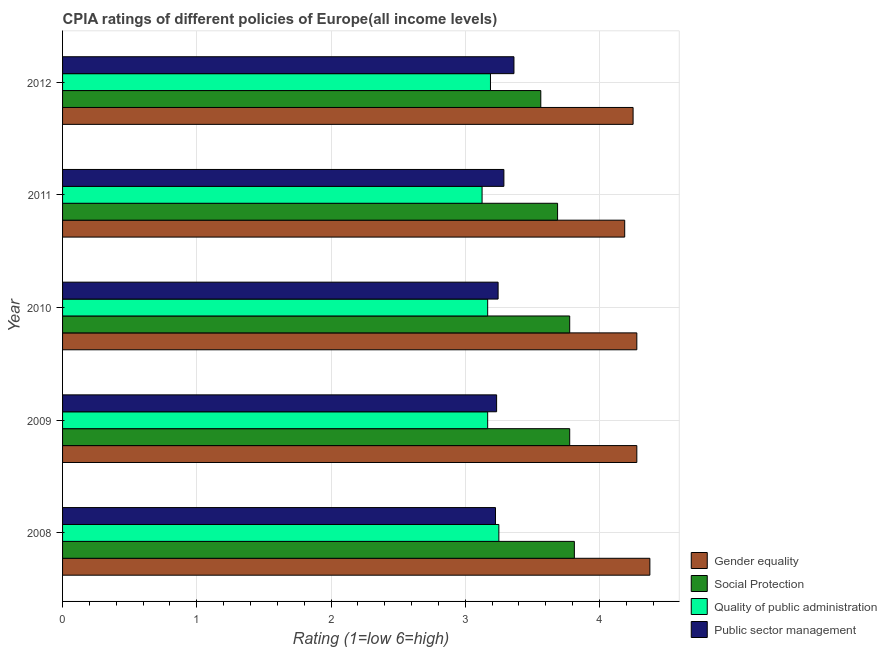How many groups of bars are there?
Give a very brief answer. 5. How many bars are there on the 5th tick from the bottom?
Offer a terse response. 4. What is the label of the 5th group of bars from the top?
Offer a terse response. 2008. In how many cases, is the number of bars for a given year not equal to the number of legend labels?
Make the answer very short. 0. What is the cpia rating of public sector management in 2010?
Give a very brief answer. 3.24. Across all years, what is the maximum cpia rating of gender equality?
Your answer should be very brief. 4.38. Across all years, what is the minimum cpia rating of quality of public administration?
Provide a succinct answer. 3.12. What is the total cpia rating of gender equality in the graph?
Ensure brevity in your answer.  21.37. What is the difference between the cpia rating of gender equality in 2009 and that in 2011?
Offer a very short reply. 0.09. What is the difference between the cpia rating of public sector management in 2009 and the cpia rating of social protection in 2011?
Ensure brevity in your answer.  -0.45. What is the average cpia rating of public sector management per year?
Offer a very short reply. 3.27. In the year 2011, what is the difference between the cpia rating of public sector management and cpia rating of quality of public administration?
Offer a terse response. 0.16. In how many years, is the cpia rating of social protection greater than 1.4 ?
Your answer should be compact. 5. What is the ratio of the cpia rating of public sector management in 2011 to that in 2012?
Make the answer very short. 0.98. Is the cpia rating of public sector management in 2010 less than that in 2011?
Ensure brevity in your answer.  Yes. Is the difference between the cpia rating of public sector management in 2009 and 2010 greater than the difference between the cpia rating of quality of public administration in 2009 and 2010?
Your answer should be very brief. No. What is the difference between the highest and the second highest cpia rating of quality of public administration?
Your response must be concise. 0.06. What is the difference between the highest and the lowest cpia rating of gender equality?
Provide a succinct answer. 0.19. In how many years, is the cpia rating of quality of public administration greater than the average cpia rating of quality of public administration taken over all years?
Keep it short and to the point. 2. Is the sum of the cpia rating of quality of public administration in 2008 and 2010 greater than the maximum cpia rating of public sector management across all years?
Keep it short and to the point. Yes. Is it the case that in every year, the sum of the cpia rating of gender equality and cpia rating of social protection is greater than the sum of cpia rating of public sector management and cpia rating of quality of public administration?
Provide a short and direct response. Yes. What does the 1st bar from the top in 2008 represents?
Give a very brief answer. Public sector management. What does the 3rd bar from the bottom in 2008 represents?
Provide a succinct answer. Quality of public administration. Is it the case that in every year, the sum of the cpia rating of gender equality and cpia rating of social protection is greater than the cpia rating of quality of public administration?
Offer a terse response. Yes. Does the graph contain any zero values?
Your response must be concise. No. Where does the legend appear in the graph?
Provide a succinct answer. Bottom right. What is the title of the graph?
Give a very brief answer. CPIA ratings of different policies of Europe(all income levels). Does "Social Assistance" appear as one of the legend labels in the graph?
Your response must be concise. No. What is the label or title of the X-axis?
Give a very brief answer. Rating (1=low 6=high). What is the Rating (1=low 6=high) of Gender equality in 2008?
Give a very brief answer. 4.38. What is the Rating (1=low 6=high) of Social Protection in 2008?
Your answer should be very brief. 3.81. What is the Rating (1=low 6=high) in Public sector management in 2008?
Provide a short and direct response. 3.23. What is the Rating (1=low 6=high) in Gender equality in 2009?
Offer a terse response. 4.28. What is the Rating (1=low 6=high) in Social Protection in 2009?
Your response must be concise. 3.78. What is the Rating (1=low 6=high) in Quality of public administration in 2009?
Offer a very short reply. 3.17. What is the Rating (1=low 6=high) of Public sector management in 2009?
Offer a terse response. 3.23. What is the Rating (1=low 6=high) in Gender equality in 2010?
Your answer should be very brief. 4.28. What is the Rating (1=low 6=high) in Social Protection in 2010?
Ensure brevity in your answer.  3.78. What is the Rating (1=low 6=high) in Quality of public administration in 2010?
Keep it short and to the point. 3.17. What is the Rating (1=low 6=high) of Public sector management in 2010?
Your answer should be very brief. 3.24. What is the Rating (1=low 6=high) of Gender equality in 2011?
Give a very brief answer. 4.19. What is the Rating (1=low 6=high) of Social Protection in 2011?
Keep it short and to the point. 3.69. What is the Rating (1=low 6=high) in Quality of public administration in 2011?
Offer a very short reply. 3.12. What is the Rating (1=low 6=high) in Public sector management in 2011?
Your answer should be very brief. 3.29. What is the Rating (1=low 6=high) in Gender equality in 2012?
Your answer should be very brief. 4.25. What is the Rating (1=low 6=high) of Social Protection in 2012?
Your answer should be very brief. 3.56. What is the Rating (1=low 6=high) of Quality of public administration in 2012?
Make the answer very short. 3.19. What is the Rating (1=low 6=high) of Public sector management in 2012?
Your answer should be very brief. 3.36. Across all years, what is the maximum Rating (1=low 6=high) in Gender equality?
Your answer should be very brief. 4.38. Across all years, what is the maximum Rating (1=low 6=high) of Social Protection?
Your response must be concise. 3.81. Across all years, what is the maximum Rating (1=low 6=high) in Public sector management?
Provide a succinct answer. 3.36. Across all years, what is the minimum Rating (1=low 6=high) of Gender equality?
Your response must be concise. 4.19. Across all years, what is the minimum Rating (1=low 6=high) of Social Protection?
Provide a succinct answer. 3.56. Across all years, what is the minimum Rating (1=low 6=high) in Quality of public administration?
Keep it short and to the point. 3.12. Across all years, what is the minimum Rating (1=low 6=high) in Public sector management?
Offer a terse response. 3.23. What is the total Rating (1=low 6=high) in Gender equality in the graph?
Provide a short and direct response. 21.37. What is the total Rating (1=low 6=high) in Social Protection in the graph?
Offer a very short reply. 18.62. What is the total Rating (1=low 6=high) of Quality of public administration in the graph?
Offer a very short reply. 15.9. What is the total Rating (1=low 6=high) of Public sector management in the graph?
Offer a very short reply. 16.35. What is the difference between the Rating (1=low 6=high) in Gender equality in 2008 and that in 2009?
Provide a succinct answer. 0.1. What is the difference between the Rating (1=low 6=high) of Social Protection in 2008 and that in 2009?
Your answer should be compact. 0.03. What is the difference between the Rating (1=low 6=high) in Quality of public administration in 2008 and that in 2009?
Give a very brief answer. 0.08. What is the difference between the Rating (1=low 6=high) in Public sector management in 2008 and that in 2009?
Your answer should be compact. -0.01. What is the difference between the Rating (1=low 6=high) of Gender equality in 2008 and that in 2010?
Offer a very short reply. 0.1. What is the difference between the Rating (1=low 6=high) in Social Protection in 2008 and that in 2010?
Provide a short and direct response. 0.03. What is the difference between the Rating (1=low 6=high) of Quality of public administration in 2008 and that in 2010?
Keep it short and to the point. 0.08. What is the difference between the Rating (1=low 6=high) of Public sector management in 2008 and that in 2010?
Offer a very short reply. -0.02. What is the difference between the Rating (1=low 6=high) in Gender equality in 2008 and that in 2011?
Provide a short and direct response. 0.19. What is the difference between the Rating (1=low 6=high) of Social Protection in 2008 and that in 2011?
Offer a terse response. 0.12. What is the difference between the Rating (1=low 6=high) in Quality of public administration in 2008 and that in 2011?
Offer a very short reply. 0.12. What is the difference between the Rating (1=low 6=high) in Public sector management in 2008 and that in 2011?
Your answer should be very brief. -0.06. What is the difference between the Rating (1=low 6=high) in Quality of public administration in 2008 and that in 2012?
Give a very brief answer. 0.06. What is the difference between the Rating (1=low 6=high) in Public sector management in 2008 and that in 2012?
Give a very brief answer. -0.14. What is the difference between the Rating (1=low 6=high) in Gender equality in 2009 and that in 2010?
Your answer should be compact. 0. What is the difference between the Rating (1=low 6=high) in Public sector management in 2009 and that in 2010?
Make the answer very short. -0.01. What is the difference between the Rating (1=low 6=high) in Gender equality in 2009 and that in 2011?
Make the answer very short. 0.09. What is the difference between the Rating (1=low 6=high) in Social Protection in 2009 and that in 2011?
Your answer should be very brief. 0.09. What is the difference between the Rating (1=low 6=high) in Quality of public administration in 2009 and that in 2011?
Ensure brevity in your answer.  0.04. What is the difference between the Rating (1=low 6=high) in Public sector management in 2009 and that in 2011?
Keep it short and to the point. -0.05. What is the difference between the Rating (1=low 6=high) in Gender equality in 2009 and that in 2012?
Offer a terse response. 0.03. What is the difference between the Rating (1=low 6=high) in Social Protection in 2009 and that in 2012?
Your answer should be very brief. 0.22. What is the difference between the Rating (1=low 6=high) of Quality of public administration in 2009 and that in 2012?
Keep it short and to the point. -0.02. What is the difference between the Rating (1=low 6=high) in Public sector management in 2009 and that in 2012?
Provide a succinct answer. -0.13. What is the difference between the Rating (1=low 6=high) in Gender equality in 2010 and that in 2011?
Your answer should be very brief. 0.09. What is the difference between the Rating (1=low 6=high) of Social Protection in 2010 and that in 2011?
Provide a short and direct response. 0.09. What is the difference between the Rating (1=low 6=high) in Quality of public administration in 2010 and that in 2011?
Keep it short and to the point. 0.04. What is the difference between the Rating (1=low 6=high) in Public sector management in 2010 and that in 2011?
Keep it short and to the point. -0.04. What is the difference between the Rating (1=low 6=high) of Gender equality in 2010 and that in 2012?
Provide a short and direct response. 0.03. What is the difference between the Rating (1=low 6=high) in Social Protection in 2010 and that in 2012?
Offer a very short reply. 0.22. What is the difference between the Rating (1=low 6=high) of Quality of public administration in 2010 and that in 2012?
Provide a succinct answer. -0.02. What is the difference between the Rating (1=low 6=high) in Public sector management in 2010 and that in 2012?
Your answer should be compact. -0.12. What is the difference between the Rating (1=low 6=high) in Gender equality in 2011 and that in 2012?
Keep it short and to the point. -0.06. What is the difference between the Rating (1=low 6=high) in Quality of public administration in 2011 and that in 2012?
Offer a terse response. -0.06. What is the difference between the Rating (1=low 6=high) of Public sector management in 2011 and that in 2012?
Make the answer very short. -0.07. What is the difference between the Rating (1=low 6=high) in Gender equality in 2008 and the Rating (1=low 6=high) in Social Protection in 2009?
Give a very brief answer. 0.6. What is the difference between the Rating (1=low 6=high) of Gender equality in 2008 and the Rating (1=low 6=high) of Quality of public administration in 2009?
Ensure brevity in your answer.  1.21. What is the difference between the Rating (1=low 6=high) of Gender equality in 2008 and the Rating (1=low 6=high) of Public sector management in 2009?
Offer a terse response. 1.14. What is the difference between the Rating (1=low 6=high) in Social Protection in 2008 and the Rating (1=low 6=high) in Quality of public administration in 2009?
Keep it short and to the point. 0.65. What is the difference between the Rating (1=low 6=high) of Social Protection in 2008 and the Rating (1=low 6=high) of Public sector management in 2009?
Give a very brief answer. 0.58. What is the difference between the Rating (1=low 6=high) of Quality of public administration in 2008 and the Rating (1=low 6=high) of Public sector management in 2009?
Your answer should be compact. 0.02. What is the difference between the Rating (1=low 6=high) in Gender equality in 2008 and the Rating (1=low 6=high) in Social Protection in 2010?
Provide a succinct answer. 0.6. What is the difference between the Rating (1=low 6=high) in Gender equality in 2008 and the Rating (1=low 6=high) in Quality of public administration in 2010?
Your response must be concise. 1.21. What is the difference between the Rating (1=low 6=high) of Gender equality in 2008 and the Rating (1=low 6=high) of Public sector management in 2010?
Offer a terse response. 1.13. What is the difference between the Rating (1=low 6=high) of Social Protection in 2008 and the Rating (1=low 6=high) of Quality of public administration in 2010?
Make the answer very short. 0.65. What is the difference between the Rating (1=low 6=high) of Social Protection in 2008 and the Rating (1=low 6=high) of Public sector management in 2010?
Offer a very short reply. 0.57. What is the difference between the Rating (1=low 6=high) of Quality of public administration in 2008 and the Rating (1=low 6=high) of Public sector management in 2010?
Your response must be concise. 0.01. What is the difference between the Rating (1=low 6=high) in Gender equality in 2008 and the Rating (1=low 6=high) in Social Protection in 2011?
Give a very brief answer. 0.69. What is the difference between the Rating (1=low 6=high) in Gender equality in 2008 and the Rating (1=low 6=high) in Public sector management in 2011?
Provide a short and direct response. 1.09. What is the difference between the Rating (1=low 6=high) in Social Protection in 2008 and the Rating (1=low 6=high) in Quality of public administration in 2011?
Give a very brief answer. 0.69. What is the difference between the Rating (1=low 6=high) in Social Protection in 2008 and the Rating (1=low 6=high) in Public sector management in 2011?
Your answer should be very brief. 0.53. What is the difference between the Rating (1=low 6=high) of Quality of public administration in 2008 and the Rating (1=low 6=high) of Public sector management in 2011?
Your answer should be compact. -0.04. What is the difference between the Rating (1=low 6=high) in Gender equality in 2008 and the Rating (1=low 6=high) in Social Protection in 2012?
Offer a very short reply. 0.81. What is the difference between the Rating (1=low 6=high) in Gender equality in 2008 and the Rating (1=low 6=high) in Quality of public administration in 2012?
Keep it short and to the point. 1.19. What is the difference between the Rating (1=low 6=high) of Gender equality in 2008 and the Rating (1=low 6=high) of Public sector management in 2012?
Make the answer very short. 1.01. What is the difference between the Rating (1=low 6=high) of Social Protection in 2008 and the Rating (1=low 6=high) of Quality of public administration in 2012?
Provide a short and direct response. 0.62. What is the difference between the Rating (1=low 6=high) of Social Protection in 2008 and the Rating (1=low 6=high) of Public sector management in 2012?
Your response must be concise. 0.45. What is the difference between the Rating (1=low 6=high) in Quality of public administration in 2008 and the Rating (1=low 6=high) in Public sector management in 2012?
Your response must be concise. -0.11. What is the difference between the Rating (1=low 6=high) of Gender equality in 2009 and the Rating (1=low 6=high) of Quality of public administration in 2010?
Keep it short and to the point. 1.11. What is the difference between the Rating (1=low 6=high) in Gender equality in 2009 and the Rating (1=low 6=high) in Public sector management in 2010?
Provide a short and direct response. 1.03. What is the difference between the Rating (1=low 6=high) in Social Protection in 2009 and the Rating (1=low 6=high) in Quality of public administration in 2010?
Give a very brief answer. 0.61. What is the difference between the Rating (1=low 6=high) in Social Protection in 2009 and the Rating (1=low 6=high) in Public sector management in 2010?
Offer a very short reply. 0.53. What is the difference between the Rating (1=low 6=high) of Quality of public administration in 2009 and the Rating (1=low 6=high) of Public sector management in 2010?
Your answer should be compact. -0.08. What is the difference between the Rating (1=low 6=high) in Gender equality in 2009 and the Rating (1=low 6=high) in Social Protection in 2011?
Offer a very short reply. 0.59. What is the difference between the Rating (1=low 6=high) of Gender equality in 2009 and the Rating (1=low 6=high) of Quality of public administration in 2011?
Provide a short and direct response. 1.15. What is the difference between the Rating (1=low 6=high) in Gender equality in 2009 and the Rating (1=low 6=high) in Public sector management in 2011?
Make the answer very short. 0.99. What is the difference between the Rating (1=low 6=high) of Social Protection in 2009 and the Rating (1=low 6=high) of Quality of public administration in 2011?
Offer a terse response. 0.65. What is the difference between the Rating (1=low 6=high) of Social Protection in 2009 and the Rating (1=low 6=high) of Public sector management in 2011?
Provide a short and direct response. 0.49. What is the difference between the Rating (1=low 6=high) of Quality of public administration in 2009 and the Rating (1=low 6=high) of Public sector management in 2011?
Your answer should be very brief. -0.12. What is the difference between the Rating (1=low 6=high) of Gender equality in 2009 and the Rating (1=low 6=high) of Social Protection in 2012?
Provide a succinct answer. 0.72. What is the difference between the Rating (1=low 6=high) in Gender equality in 2009 and the Rating (1=low 6=high) in Quality of public administration in 2012?
Your response must be concise. 1.09. What is the difference between the Rating (1=low 6=high) in Gender equality in 2009 and the Rating (1=low 6=high) in Public sector management in 2012?
Provide a short and direct response. 0.92. What is the difference between the Rating (1=low 6=high) of Social Protection in 2009 and the Rating (1=low 6=high) of Quality of public administration in 2012?
Your answer should be very brief. 0.59. What is the difference between the Rating (1=low 6=high) of Social Protection in 2009 and the Rating (1=low 6=high) of Public sector management in 2012?
Offer a terse response. 0.42. What is the difference between the Rating (1=low 6=high) in Quality of public administration in 2009 and the Rating (1=low 6=high) in Public sector management in 2012?
Ensure brevity in your answer.  -0.2. What is the difference between the Rating (1=low 6=high) in Gender equality in 2010 and the Rating (1=low 6=high) in Social Protection in 2011?
Keep it short and to the point. 0.59. What is the difference between the Rating (1=low 6=high) in Gender equality in 2010 and the Rating (1=low 6=high) in Quality of public administration in 2011?
Your answer should be very brief. 1.15. What is the difference between the Rating (1=low 6=high) of Gender equality in 2010 and the Rating (1=low 6=high) of Public sector management in 2011?
Your answer should be compact. 0.99. What is the difference between the Rating (1=low 6=high) in Social Protection in 2010 and the Rating (1=low 6=high) in Quality of public administration in 2011?
Ensure brevity in your answer.  0.65. What is the difference between the Rating (1=low 6=high) of Social Protection in 2010 and the Rating (1=low 6=high) of Public sector management in 2011?
Your response must be concise. 0.49. What is the difference between the Rating (1=low 6=high) of Quality of public administration in 2010 and the Rating (1=low 6=high) of Public sector management in 2011?
Make the answer very short. -0.12. What is the difference between the Rating (1=low 6=high) of Gender equality in 2010 and the Rating (1=low 6=high) of Social Protection in 2012?
Provide a short and direct response. 0.72. What is the difference between the Rating (1=low 6=high) of Gender equality in 2010 and the Rating (1=low 6=high) of Quality of public administration in 2012?
Your answer should be compact. 1.09. What is the difference between the Rating (1=low 6=high) of Gender equality in 2010 and the Rating (1=low 6=high) of Public sector management in 2012?
Ensure brevity in your answer.  0.92. What is the difference between the Rating (1=low 6=high) in Social Protection in 2010 and the Rating (1=low 6=high) in Quality of public administration in 2012?
Your response must be concise. 0.59. What is the difference between the Rating (1=low 6=high) in Social Protection in 2010 and the Rating (1=low 6=high) in Public sector management in 2012?
Make the answer very short. 0.42. What is the difference between the Rating (1=low 6=high) of Quality of public administration in 2010 and the Rating (1=low 6=high) of Public sector management in 2012?
Offer a terse response. -0.2. What is the difference between the Rating (1=low 6=high) of Gender equality in 2011 and the Rating (1=low 6=high) of Public sector management in 2012?
Provide a short and direct response. 0.82. What is the difference between the Rating (1=low 6=high) in Social Protection in 2011 and the Rating (1=low 6=high) in Public sector management in 2012?
Keep it short and to the point. 0.33. What is the difference between the Rating (1=low 6=high) in Quality of public administration in 2011 and the Rating (1=low 6=high) in Public sector management in 2012?
Make the answer very short. -0.24. What is the average Rating (1=low 6=high) in Gender equality per year?
Your response must be concise. 4.27. What is the average Rating (1=low 6=high) in Social Protection per year?
Make the answer very short. 3.72. What is the average Rating (1=low 6=high) in Quality of public administration per year?
Your answer should be compact. 3.18. What is the average Rating (1=low 6=high) of Public sector management per year?
Offer a very short reply. 3.27. In the year 2008, what is the difference between the Rating (1=low 6=high) in Gender equality and Rating (1=low 6=high) in Social Protection?
Provide a succinct answer. 0.56. In the year 2008, what is the difference between the Rating (1=low 6=high) of Gender equality and Rating (1=low 6=high) of Public sector management?
Give a very brief answer. 1.15. In the year 2008, what is the difference between the Rating (1=low 6=high) of Social Protection and Rating (1=low 6=high) of Quality of public administration?
Keep it short and to the point. 0.56. In the year 2008, what is the difference between the Rating (1=low 6=high) in Social Protection and Rating (1=low 6=high) in Public sector management?
Your response must be concise. 0.59. In the year 2008, what is the difference between the Rating (1=low 6=high) of Quality of public administration and Rating (1=low 6=high) of Public sector management?
Give a very brief answer. 0.03. In the year 2009, what is the difference between the Rating (1=low 6=high) in Gender equality and Rating (1=low 6=high) in Social Protection?
Offer a terse response. 0.5. In the year 2009, what is the difference between the Rating (1=low 6=high) in Gender equality and Rating (1=low 6=high) in Public sector management?
Offer a very short reply. 1.04. In the year 2009, what is the difference between the Rating (1=low 6=high) in Social Protection and Rating (1=low 6=high) in Quality of public administration?
Your answer should be compact. 0.61. In the year 2009, what is the difference between the Rating (1=low 6=high) of Social Protection and Rating (1=low 6=high) of Public sector management?
Keep it short and to the point. 0.54. In the year 2009, what is the difference between the Rating (1=low 6=high) in Quality of public administration and Rating (1=low 6=high) in Public sector management?
Provide a succinct answer. -0.07. In the year 2010, what is the difference between the Rating (1=low 6=high) in Gender equality and Rating (1=low 6=high) in Public sector management?
Ensure brevity in your answer.  1.03. In the year 2010, what is the difference between the Rating (1=low 6=high) in Social Protection and Rating (1=low 6=high) in Quality of public administration?
Your response must be concise. 0.61. In the year 2010, what is the difference between the Rating (1=low 6=high) of Social Protection and Rating (1=low 6=high) of Public sector management?
Your answer should be very brief. 0.53. In the year 2010, what is the difference between the Rating (1=low 6=high) in Quality of public administration and Rating (1=low 6=high) in Public sector management?
Your answer should be very brief. -0.08. In the year 2011, what is the difference between the Rating (1=low 6=high) in Gender equality and Rating (1=low 6=high) in Social Protection?
Your answer should be very brief. 0.5. In the year 2011, what is the difference between the Rating (1=low 6=high) of Gender equality and Rating (1=low 6=high) of Quality of public administration?
Your answer should be compact. 1.06. In the year 2011, what is the difference between the Rating (1=low 6=high) in Gender equality and Rating (1=low 6=high) in Public sector management?
Provide a succinct answer. 0.9. In the year 2011, what is the difference between the Rating (1=low 6=high) of Social Protection and Rating (1=low 6=high) of Quality of public administration?
Provide a short and direct response. 0.56. In the year 2011, what is the difference between the Rating (1=low 6=high) in Social Protection and Rating (1=low 6=high) in Public sector management?
Offer a terse response. 0.4. In the year 2011, what is the difference between the Rating (1=low 6=high) of Quality of public administration and Rating (1=low 6=high) of Public sector management?
Your answer should be very brief. -0.16. In the year 2012, what is the difference between the Rating (1=low 6=high) in Gender equality and Rating (1=low 6=high) in Social Protection?
Keep it short and to the point. 0.69. In the year 2012, what is the difference between the Rating (1=low 6=high) in Gender equality and Rating (1=low 6=high) in Public sector management?
Provide a short and direct response. 0.89. In the year 2012, what is the difference between the Rating (1=low 6=high) of Social Protection and Rating (1=low 6=high) of Quality of public administration?
Make the answer very short. 0.38. In the year 2012, what is the difference between the Rating (1=low 6=high) in Quality of public administration and Rating (1=low 6=high) in Public sector management?
Offer a very short reply. -0.17. What is the ratio of the Rating (1=low 6=high) in Gender equality in 2008 to that in 2009?
Your answer should be very brief. 1.02. What is the ratio of the Rating (1=low 6=high) in Social Protection in 2008 to that in 2009?
Offer a very short reply. 1.01. What is the ratio of the Rating (1=low 6=high) of Quality of public administration in 2008 to that in 2009?
Provide a short and direct response. 1.03. What is the ratio of the Rating (1=low 6=high) of Gender equality in 2008 to that in 2010?
Your answer should be very brief. 1.02. What is the ratio of the Rating (1=low 6=high) in Social Protection in 2008 to that in 2010?
Make the answer very short. 1.01. What is the ratio of the Rating (1=low 6=high) of Quality of public administration in 2008 to that in 2010?
Provide a succinct answer. 1.03. What is the ratio of the Rating (1=low 6=high) in Gender equality in 2008 to that in 2011?
Your answer should be very brief. 1.04. What is the ratio of the Rating (1=low 6=high) of Social Protection in 2008 to that in 2011?
Provide a succinct answer. 1.03. What is the ratio of the Rating (1=low 6=high) in Quality of public administration in 2008 to that in 2011?
Your response must be concise. 1.04. What is the ratio of the Rating (1=low 6=high) of Gender equality in 2008 to that in 2012?
Provide a succinct answer. 1.03. What is the ratio of the Rating (1=low 6=high) in Social Protection in 2008 to that in 2012?
Offer a terse response. 1.07. What is the ratio of the Rating (1=low 6=high) of Quality of public administration in 2008 to that in 2012?
Ensure brevity in your answer.  1.02. What is the ratio of the Rating (1=low 6=high) of Public sector management in 2008 to that in 2012?
Ensure brevity in your answer.  0.96. What is the ratio of the Rating (1=low 6=high) in Gender equality in 2009 to that in 2010?
Offer a very short reply. 1. What is the ratio of the Rating (1=low 6=high) in Gender equality in 2009 to that in 2011?
Keep it short and to the point. 1.02. What is the ratio of the Rating (1=low 6=high) in Social Protection in 2009 to that in 2011?
Your answer should be very brief. 1.02. What is the ratio of the Rating (1=low 6=high) of Quality of public administration in 2009 to that in 2011?
Your answer should be very brief. 1.01. What is the ratio of the Rating (1=low 6=high) in Public sector management in 2009 to that in 2011?
Offer a terse response. 0.98. What is the ratio of the Rating (1=low 6=high) of Gender equality in 2009 to that in 2012?
Provide a succinct answer. 1.01. What is the ratio of the Rating (1=low 6=high) of Social Protection in 2009 to that in 2012?
Your response must be concise. 1.06. What is the ratio of the Rating (1=low 6=high) in Public sector management in 2009 to that in 2012?
Offer a very short reply. 0.96. What is the ratio of the Rating (1=low 6=high) of Gender equality in 2010 to that in 2011?
Ensure brevity in your answer.  1.02. What is the ratio of the Rating (1=low 6=high) in Social Protection in 2010 to that in 2011?
Give a very brief answer. 1.02. What is the ratio of the Rating (1=low 6=high) in Quality of public administration in 2010 to that in 2011?
Your response must be concise. 1.01. What is the ratio of the Rating (1=low 6=high) in Public sector management in 2010 to that in 2011?
Make the answer very short. 0.99. What is the ratio of the Rating (1=low 6=high) of Gender equality in 2010 to that in 2012?
Offer a terse response. 1.01. What is the ratio of the Rating (1=low 6=high) of Social Protection in 2010 to that in 2012?
Give a very brief answer. 1.06. What is the ratio of the Rating (1=low 6=high) of Public sector management in 2010 to that in 2012?
Give a very brief answer. 0.96. What is the ratio of the Rating (1=low 6=high) in Gender equality in 2011 to that in 2012?
Your response must be concise. 0.99. What is the ratio of the Rating (1=low 6=high) in Social Protection in 2011 to that in 2012?
Make the answer very short. 1.04. What is the ratio of the Rating (1=low 6=high) of Quality of public administration in 2011 to that in 2012?
Your answer should be very brief. 0.98. What is the ratio of the Rating (1=low 6=high) of Public sector management in 2011 to that in 2012?
Give a very brief answer. 0.98. What is the difference between the highest and the second highest Rating (1=low 6=high) of Gender equality?
Your answer should be very brief. 0.1. What is the difference between the highest and the second highest Rating (1=low 6=high) in Social Protection?
Provide a succinct answer. 0.03. What is the difference between the highest and the second highest Rating (1=low 6=high) of Quality of public administration?
Keep it short and to the point. 0.06. What is the difference between the highest and the second highest Rating (1=low 6=high) of Public sector management?
Your answer should be compact. 0.07. What is the difference between the highest and the lowest Rating (1=low 6=high) of Gender equality?
Your response must be concise. 0.19. What is the difference between the highest and the lowest Rating (1=low 6=high) in Public sector management?
Provide a succinct answer. 0.14. 